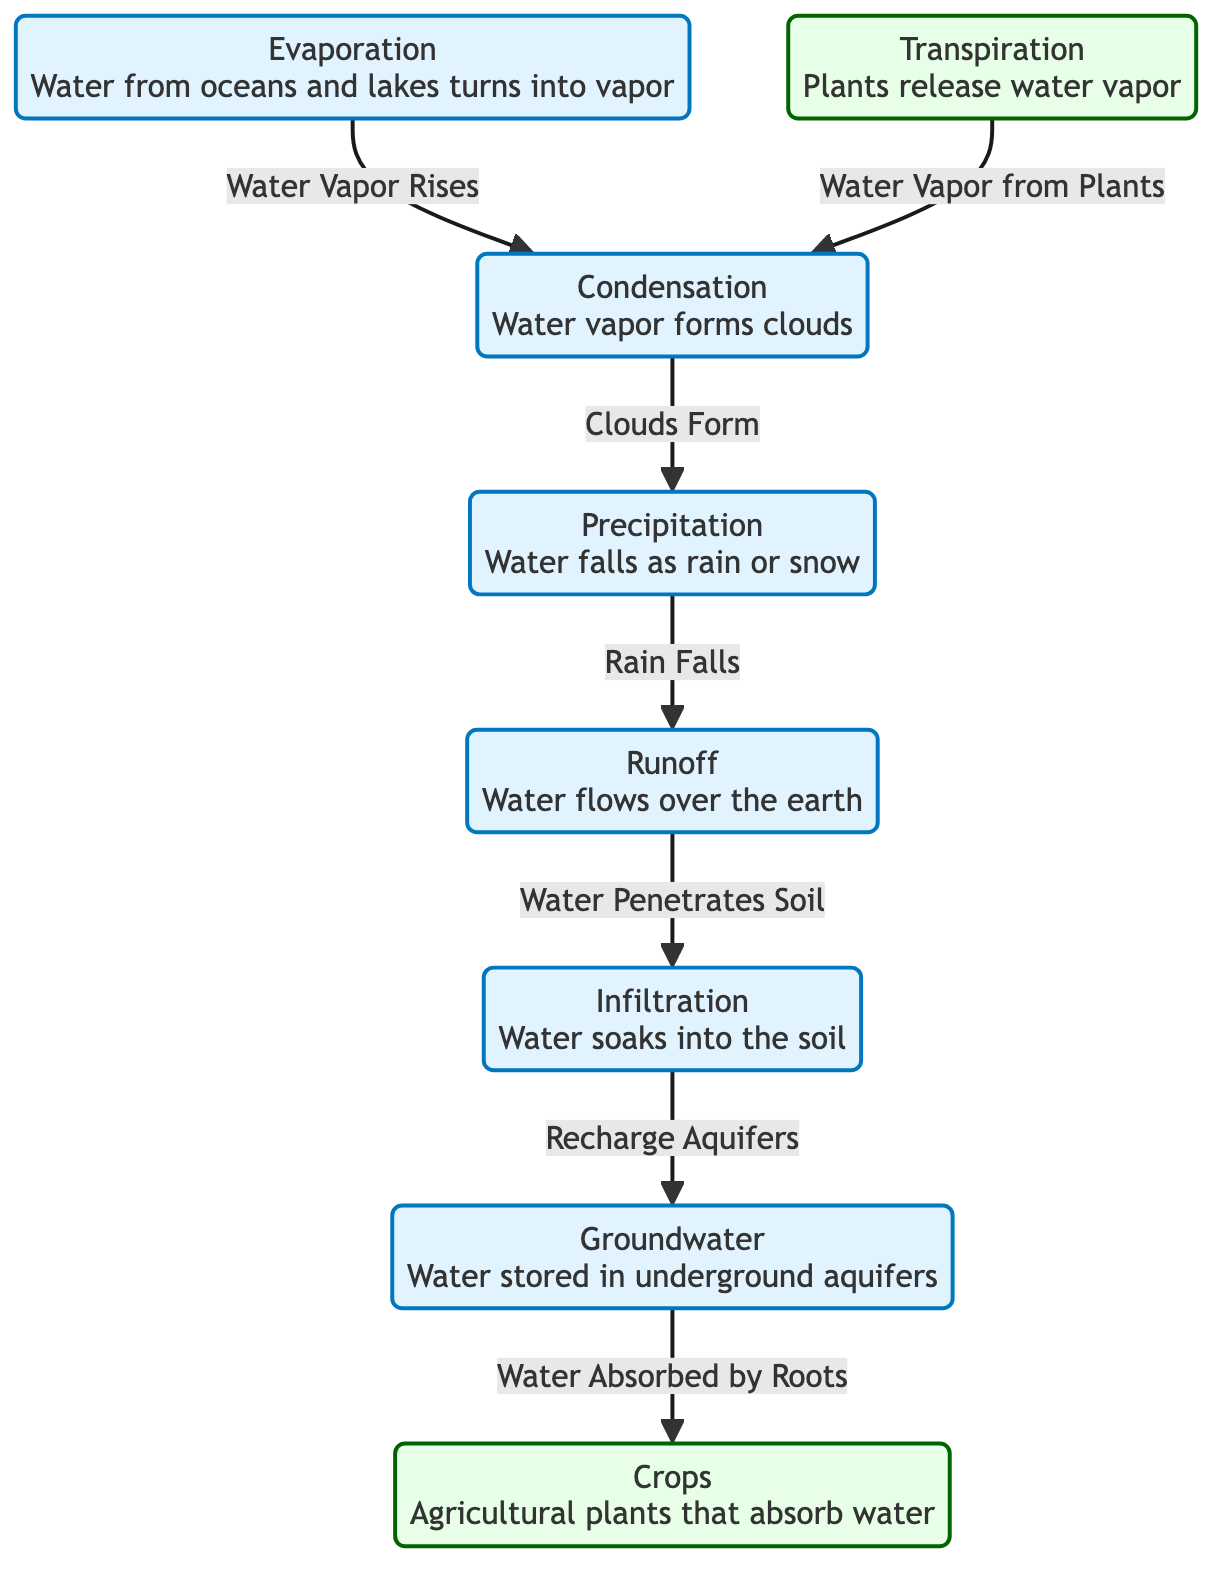What is the first process in the water cycle? The diagram indicates that evaporation is the first process, where water from oceans and lakes turns into vapor.
Answer: Evaporation How many agricultural processes are shown in the diagram? The diagram lists two agricultural processes: transpiration and crops. Therefore, the total count is two.
Answer: 2 What is the last phase of the water cycle before water reaches crops? According to the diagram, the last phase before water reaches crops is groundwater, where the water is stored in underground aquifers and later absorbed by plant roots.
Answer: Groundwater Which process is responsible for the formation of clouds? The diagram shows that condensation is the process responsible for forming clouds when water vapor collects together.
Answer: Condensation What happens during precipitation in the water cycle? The diagram states that during precipitation, water falls as rain or snow, directly indicating the type of event occurring in this phase.
Answer: Rain or snow How does water contribute to crop growth after precipitation? Water from precipitation flows over the earth as runoff, penetrates the soil during infiltration, and recharges the groundwater, which is then absorbed by crop roots, indicating its role in crop growth.
Answer: Water absorbed by roots Which agricultural process is involved in releasing water vapor back into the atmosphere? The diagram shows that transpiration is the process by which plants release water vapor into the atmosphere.
Answer: Transpiration What is the main effect of transpiration on the water cycle? Transpiration allows plants to release water vapor, which then contributes to condensation, indicating a cyclic connection in the water cycle.
Answer: Contributes to condensation What is the relationship between infiltration and groundwater? The diagram indicates that infiltration recharges aquifers, showing that water soaking into the soil leads to the storage of water as groundwater.
Answer: Recharge aquifers 